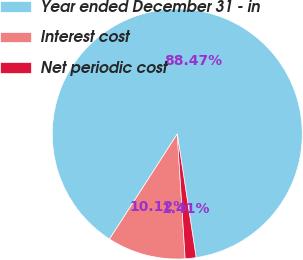Convert chart to OTSL. <chart><loc_0><loc_0><loc_500><loc_500><pie_chart><fcel>Year ended December 31 - in<fcel>Interest cost<fcel>Net periodic cost<nl><fcel>88.47%<fcel>10.12%<fcel>1.41%<nl></chart> 